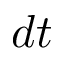<formula> <loc_0><loc_0><loc_500><loc_500>d t</formula> 